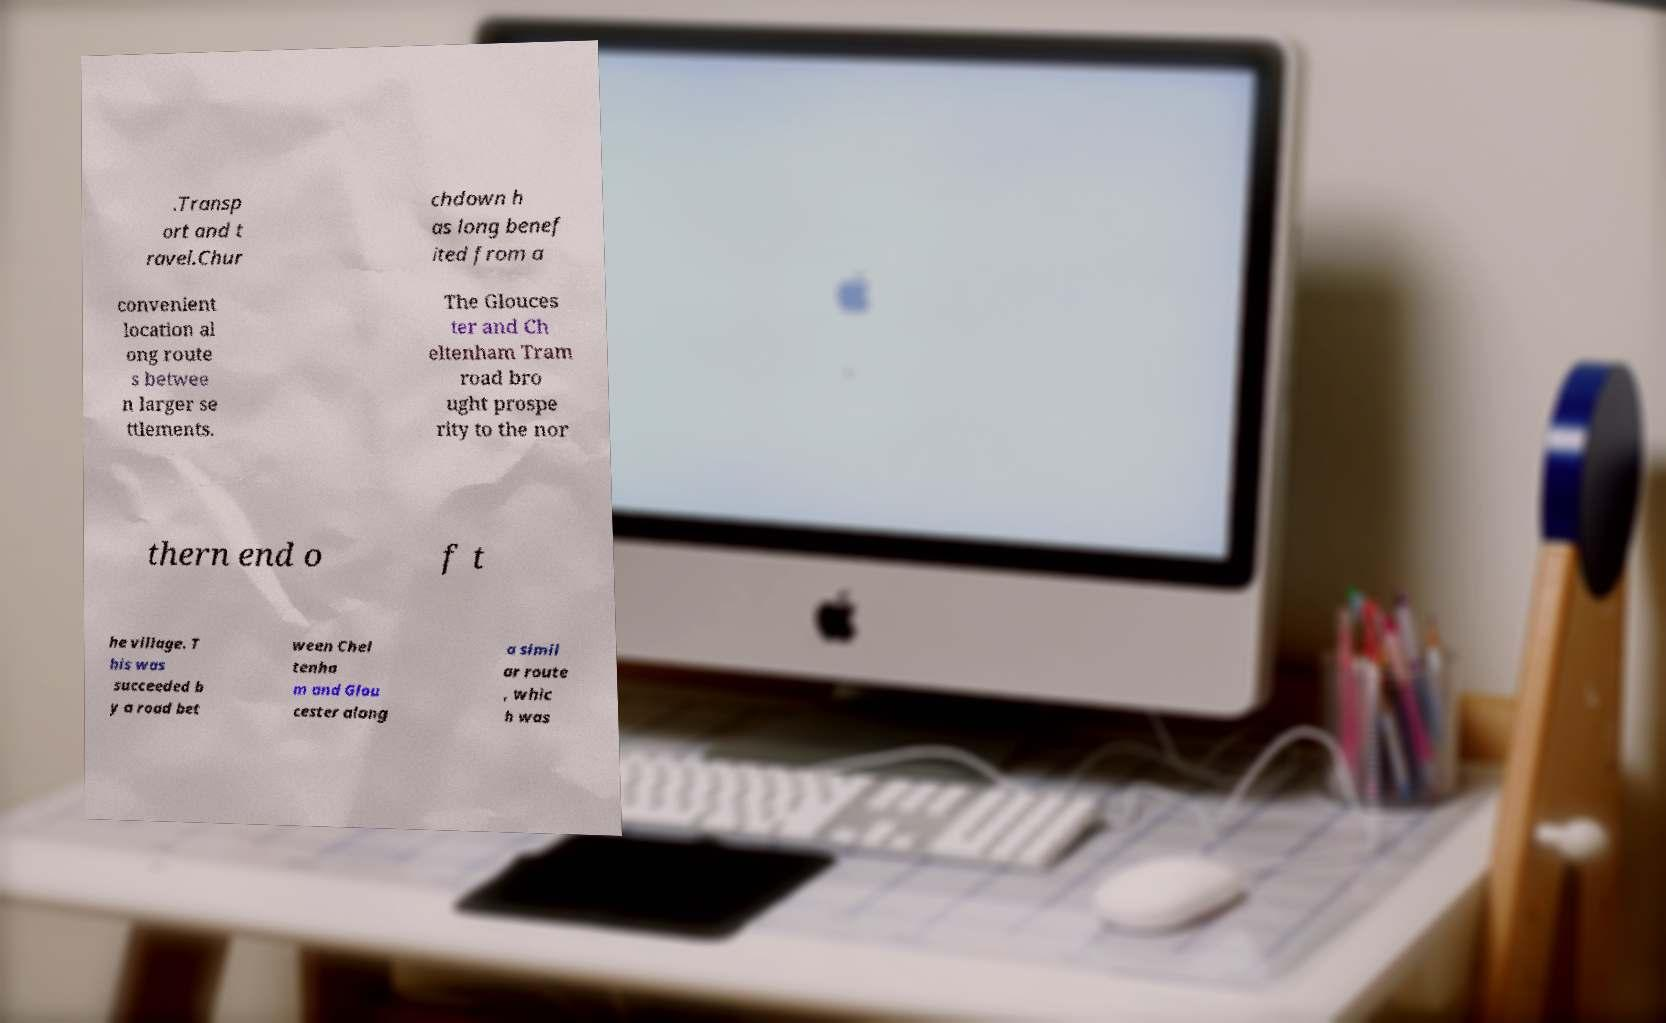Could you assist in decoding the text presented in this image and type it out clearly? .Transp ort and t ravel.Chur chdown h as long benef ited from a convenient location al ong route s betwee n larger se ttlements. The Glouces ter and Ch eltenham Tram road bro ught prospe rity to the nor thern end o f t he village. T his was succeeded b y a road bet ween Chel tenha m and Glou cester along a simil ar route , whic h was 